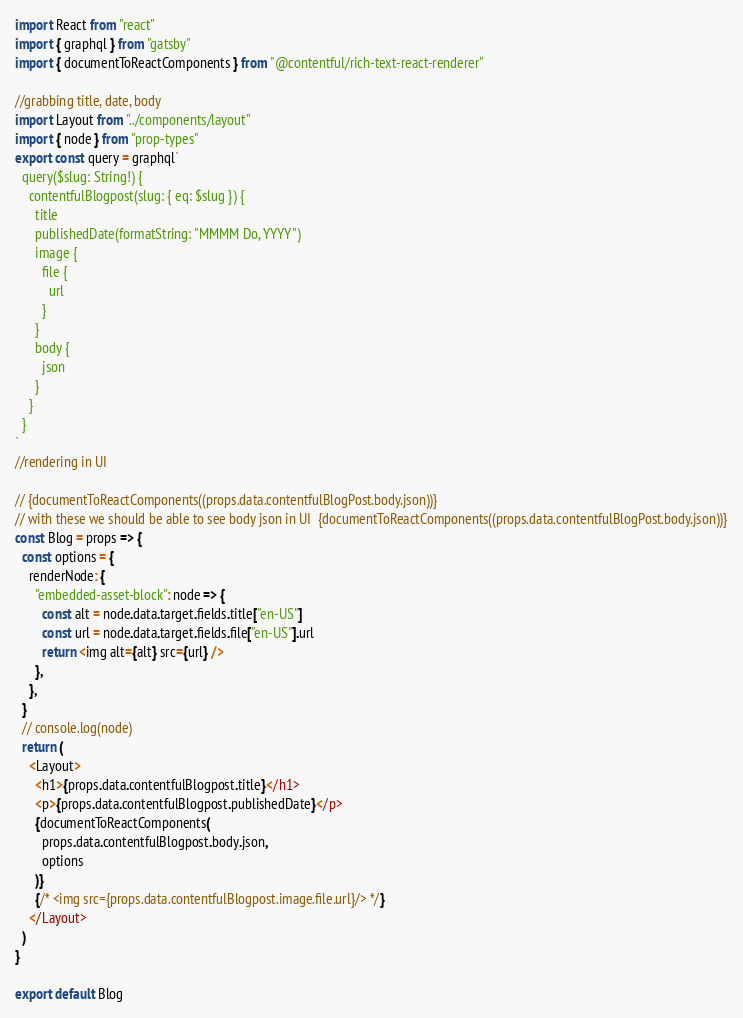<code> <loc_0><loc_0><loc_500><loc_500><_JavaScript_>





import React from "react"
import { graphql } from "gatsby"
import { documentToReactComponents } from "@contentful/rich-text-react-renderer"

//grabbing title, date, body
import Layout from "../components/layout"
import { node } from "prop-types"
export const query = graphql`
  query($slug: String!) {
    contentfulBlogpost(slug: { eq: $slug }) {
      title
      publishedDate(formatString: "MMMM Do, YYYY")
      image {
        file {
          url
        }
      }
      body {
        json
      }
    }
  }
`
//rendering in UI

// {documentToReactComponents((props.data.contentfulBlogPost.body.json))}
// with these we should be able to see body json in UI  {documentToReactComponents((props.data.contentfulBlogPost.body.json))}
const Blog = props => {
  const options = {
    renderNode: {
      "embedded-asset-block": node => {
        const alt = node.data.target.fields.title["en-US"]
        const url = node.data.target.fields.file["en-US"].url
        return <img alt={alt} src={url} />
      },
    },
  }
  // console.log(node)
  return (
    <Layout>
      <h1>{props.data.contentfulBlogpost.title}</h1>
      <p>{props.data.contentfulBlogpost.publishedDate}</p>
      {documentToReactComponents(
        props.data.contentfulBlogpost.body.json,
        options
      )}
      {/* <img src={props.data.contentfulBlogpost.image.file.url}/> */}
    </Layout>
  )
}

export default Blog
</code> 